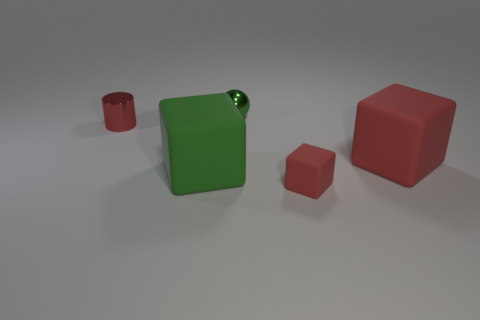Add 4 green metallic objects. How many objects exist? 9 Subtract all large red cubes. How many cubes are left? 2 Add 1 red cylinders. How many red cylinders exist? 2 Subtract all green blocks. How many blocks are left? 2 Subtract 0 cyan cylinders. How many objects are left? 5 Subtract all cylinders. How many objects are left? 4 Subtract all purple blocks. Subtract all blue cylinders. How many blocks are left? 3 Subtract all green cylinders. How many red cubes are left? 2 Subtract all red matte things. Subtract all big cyan matte cylinders. How many objects are left? 3 Add 2 small green metal objects. How many small green metal objects are left? 3 